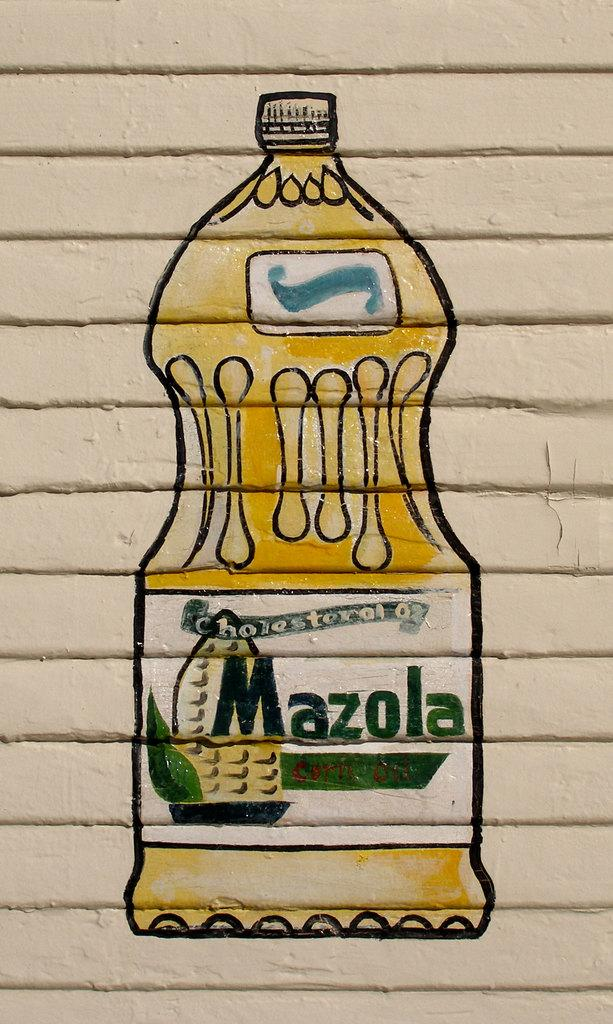<image>
Give a short and clear explanation of the subsequent image. An artists drawing depicts a bottle of Mazola oil. 